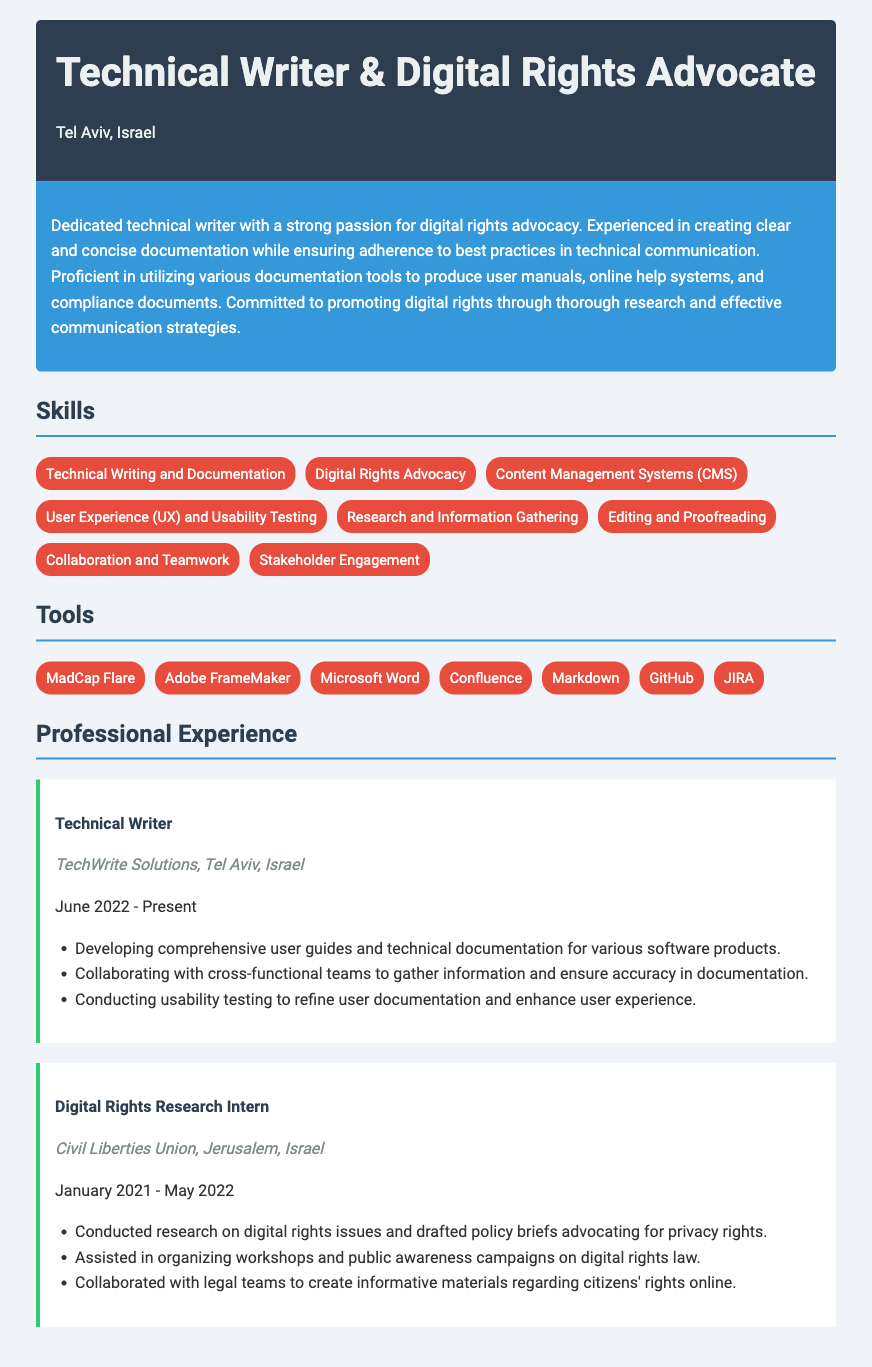what is the profession of the individual? The individual is identified as a Technical Writer and Digital Rights Advocate.
Answer: Technical Writer & Digital Rights Advocate where is the individual located? The document specifies that the individual is located in Tel Aviv, Israel.
Answer: Tel Aviv, Israel what is one of the tools the individual is proficient in? The document lists several tools, one of which is MadCap Flare.
Answer: MadCap Flare what is the duration of the individual's role at TechWrite Solutions? The individual has been in the role since June 2022, which is ongoing as of the document date.
Answer: June 2022 - Present what type of organization did the individual intern with for digital rights research? The internship was with the Civil Liberties Union.
Answer: Civil Liberties Union how many skills does the individual list in the document? The document lists eight distinct skills under the skills section.
Answer: eight what was one responsibility of the Technical Writer role? One responsibility mentioned is developing comprehensive user guides and technical documentation.
Answer: Developing comprehensive user guides and technical documentation what is the purpose of the summary section? The summary section provides a brief overview of the individual’s qualifications and focus areas.
Answer: Overview of qualifications and focus areas what type of documents does the individual create at TechWrite Solutions? The individual creates user guides and technical documentation for software products.
Answer: User guides and technical documentation 